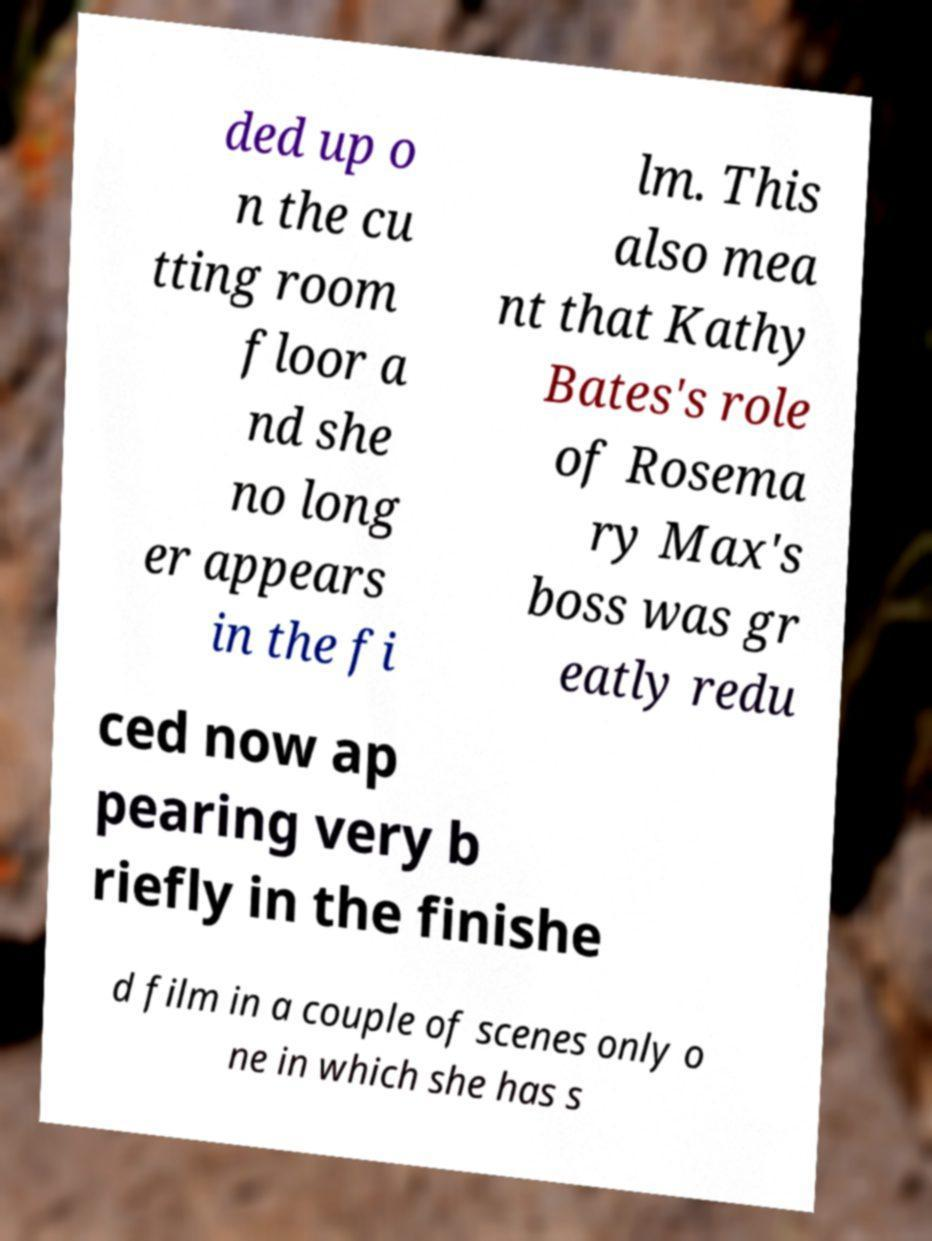There's text embedded in this image that I need extracted. Can you transcribe it verbatim? ded up o n the cu tting room floor a nd she no long er appears in the fi lm. This also mea nt that Kathy Bates's role of Rosema ry Max's boss was gr eatly redu ced now ap pearing very b riefly in the finishe d film in a couple of scenes only o ne in which she has s 